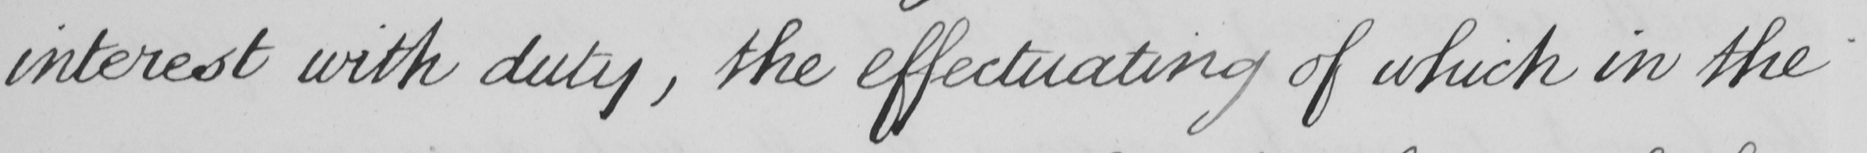Transcribe the text shown in this historical manuscript line. interest with duty , the effectuating of which in the 